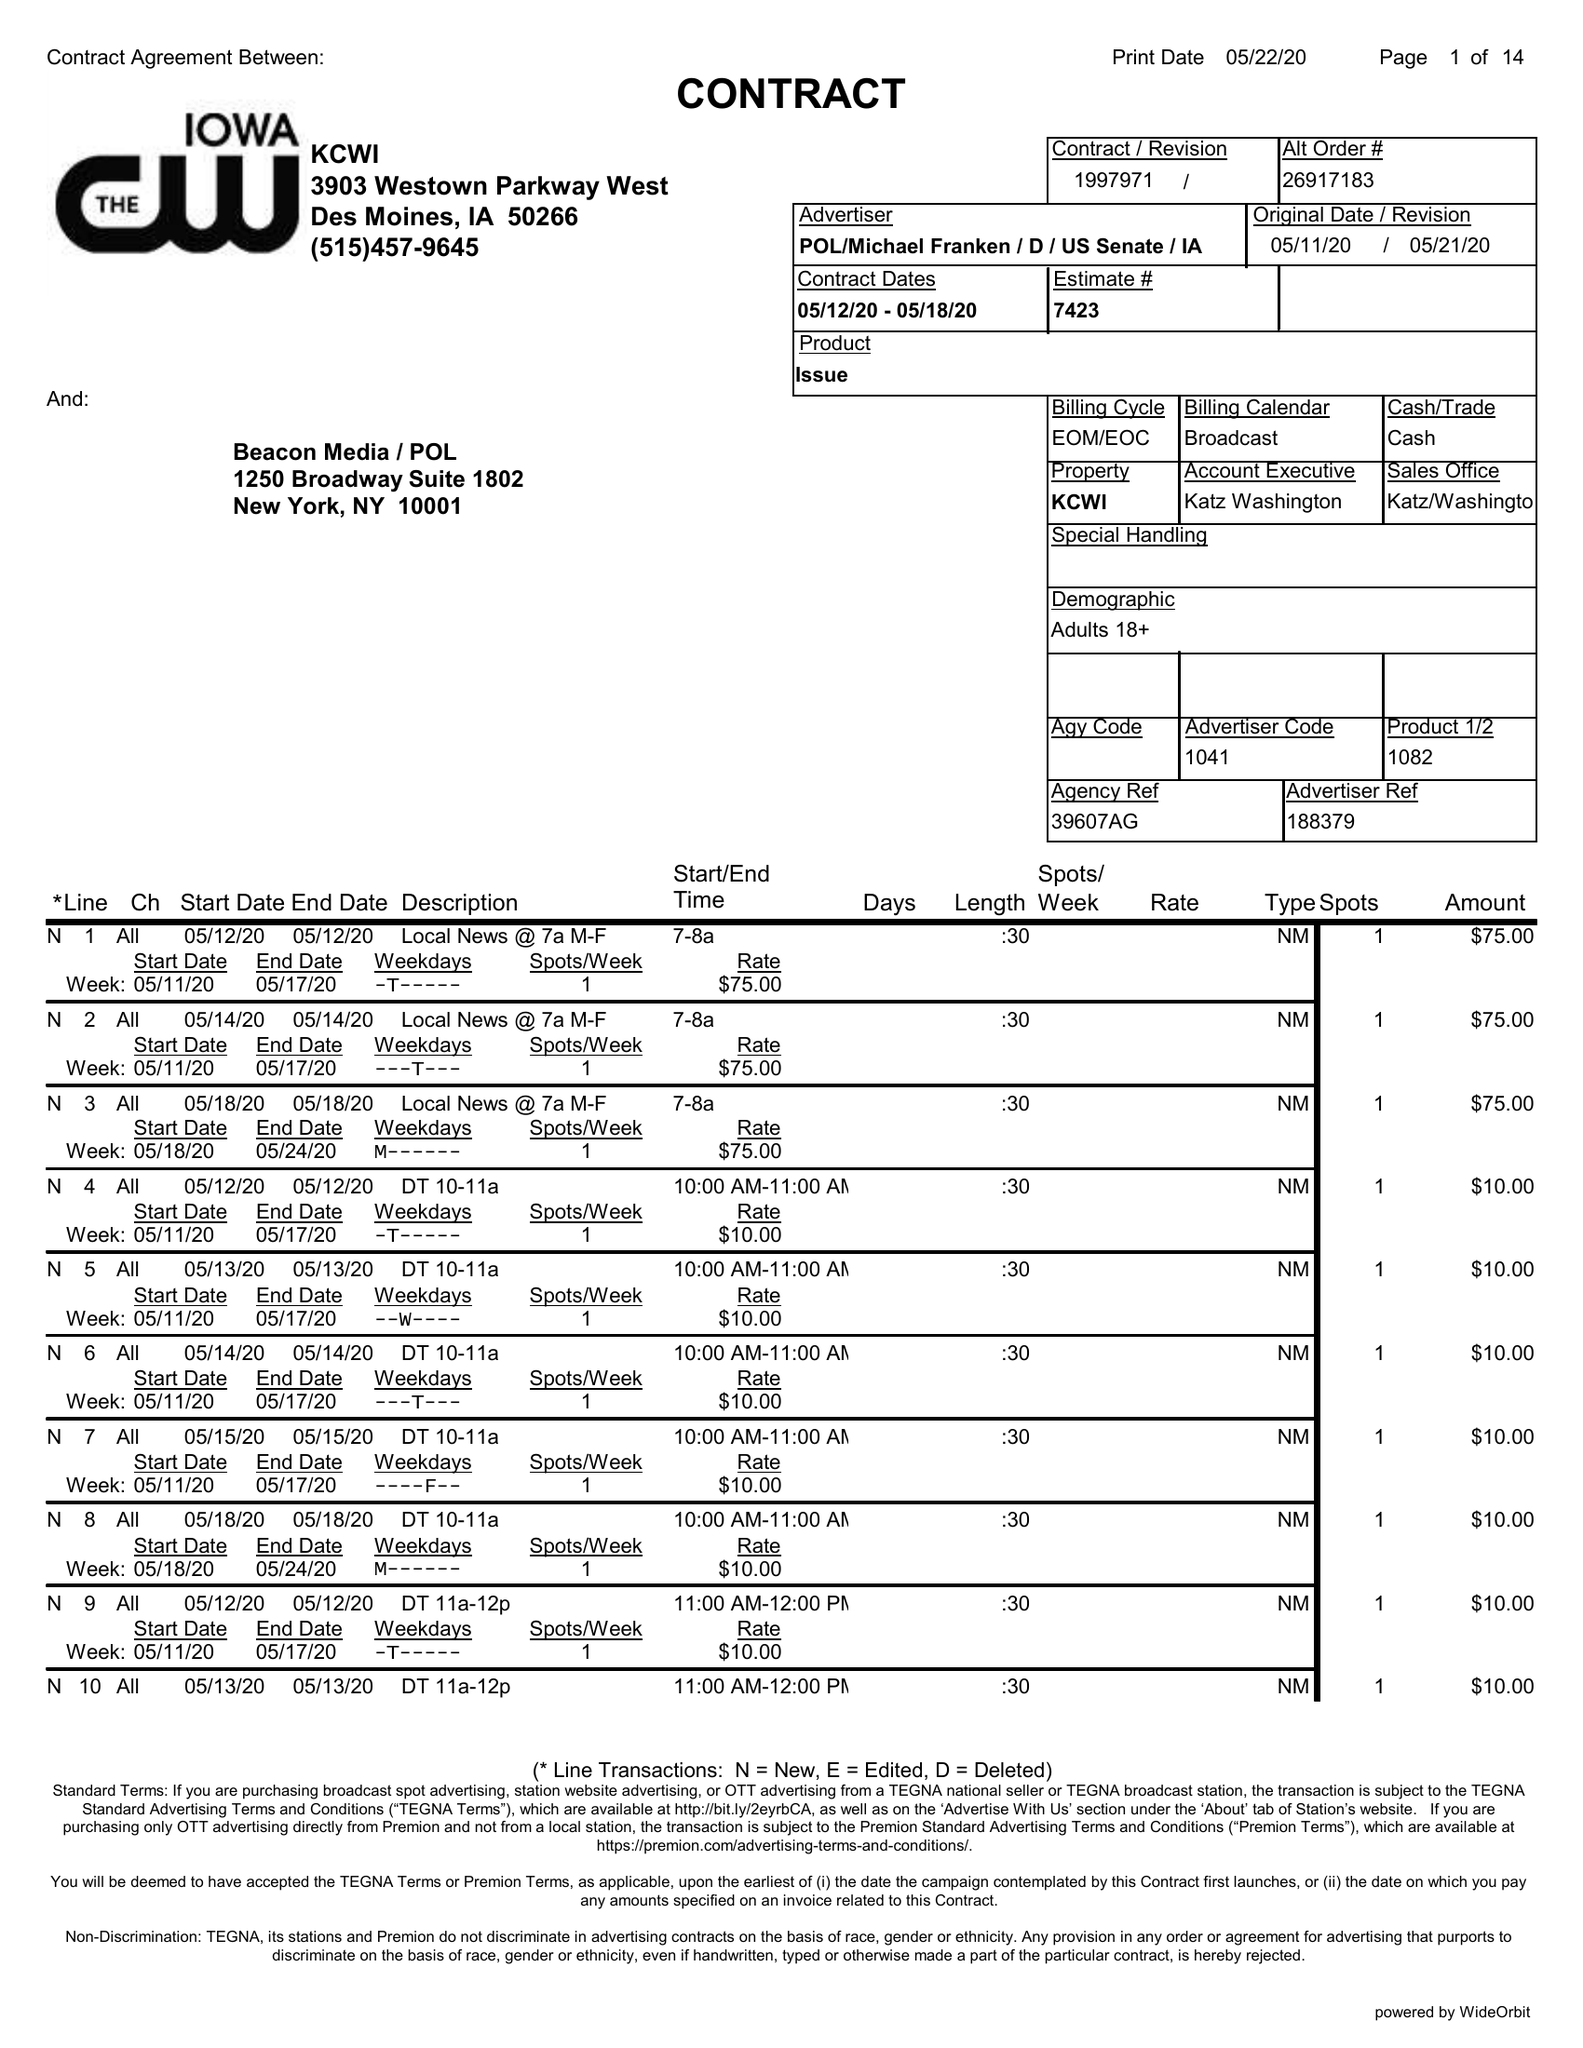What is the value for the advertiser?
Answer the question using a single word or phrase. POL/MICHAELFRANKEN/D/USSENATE/IA 